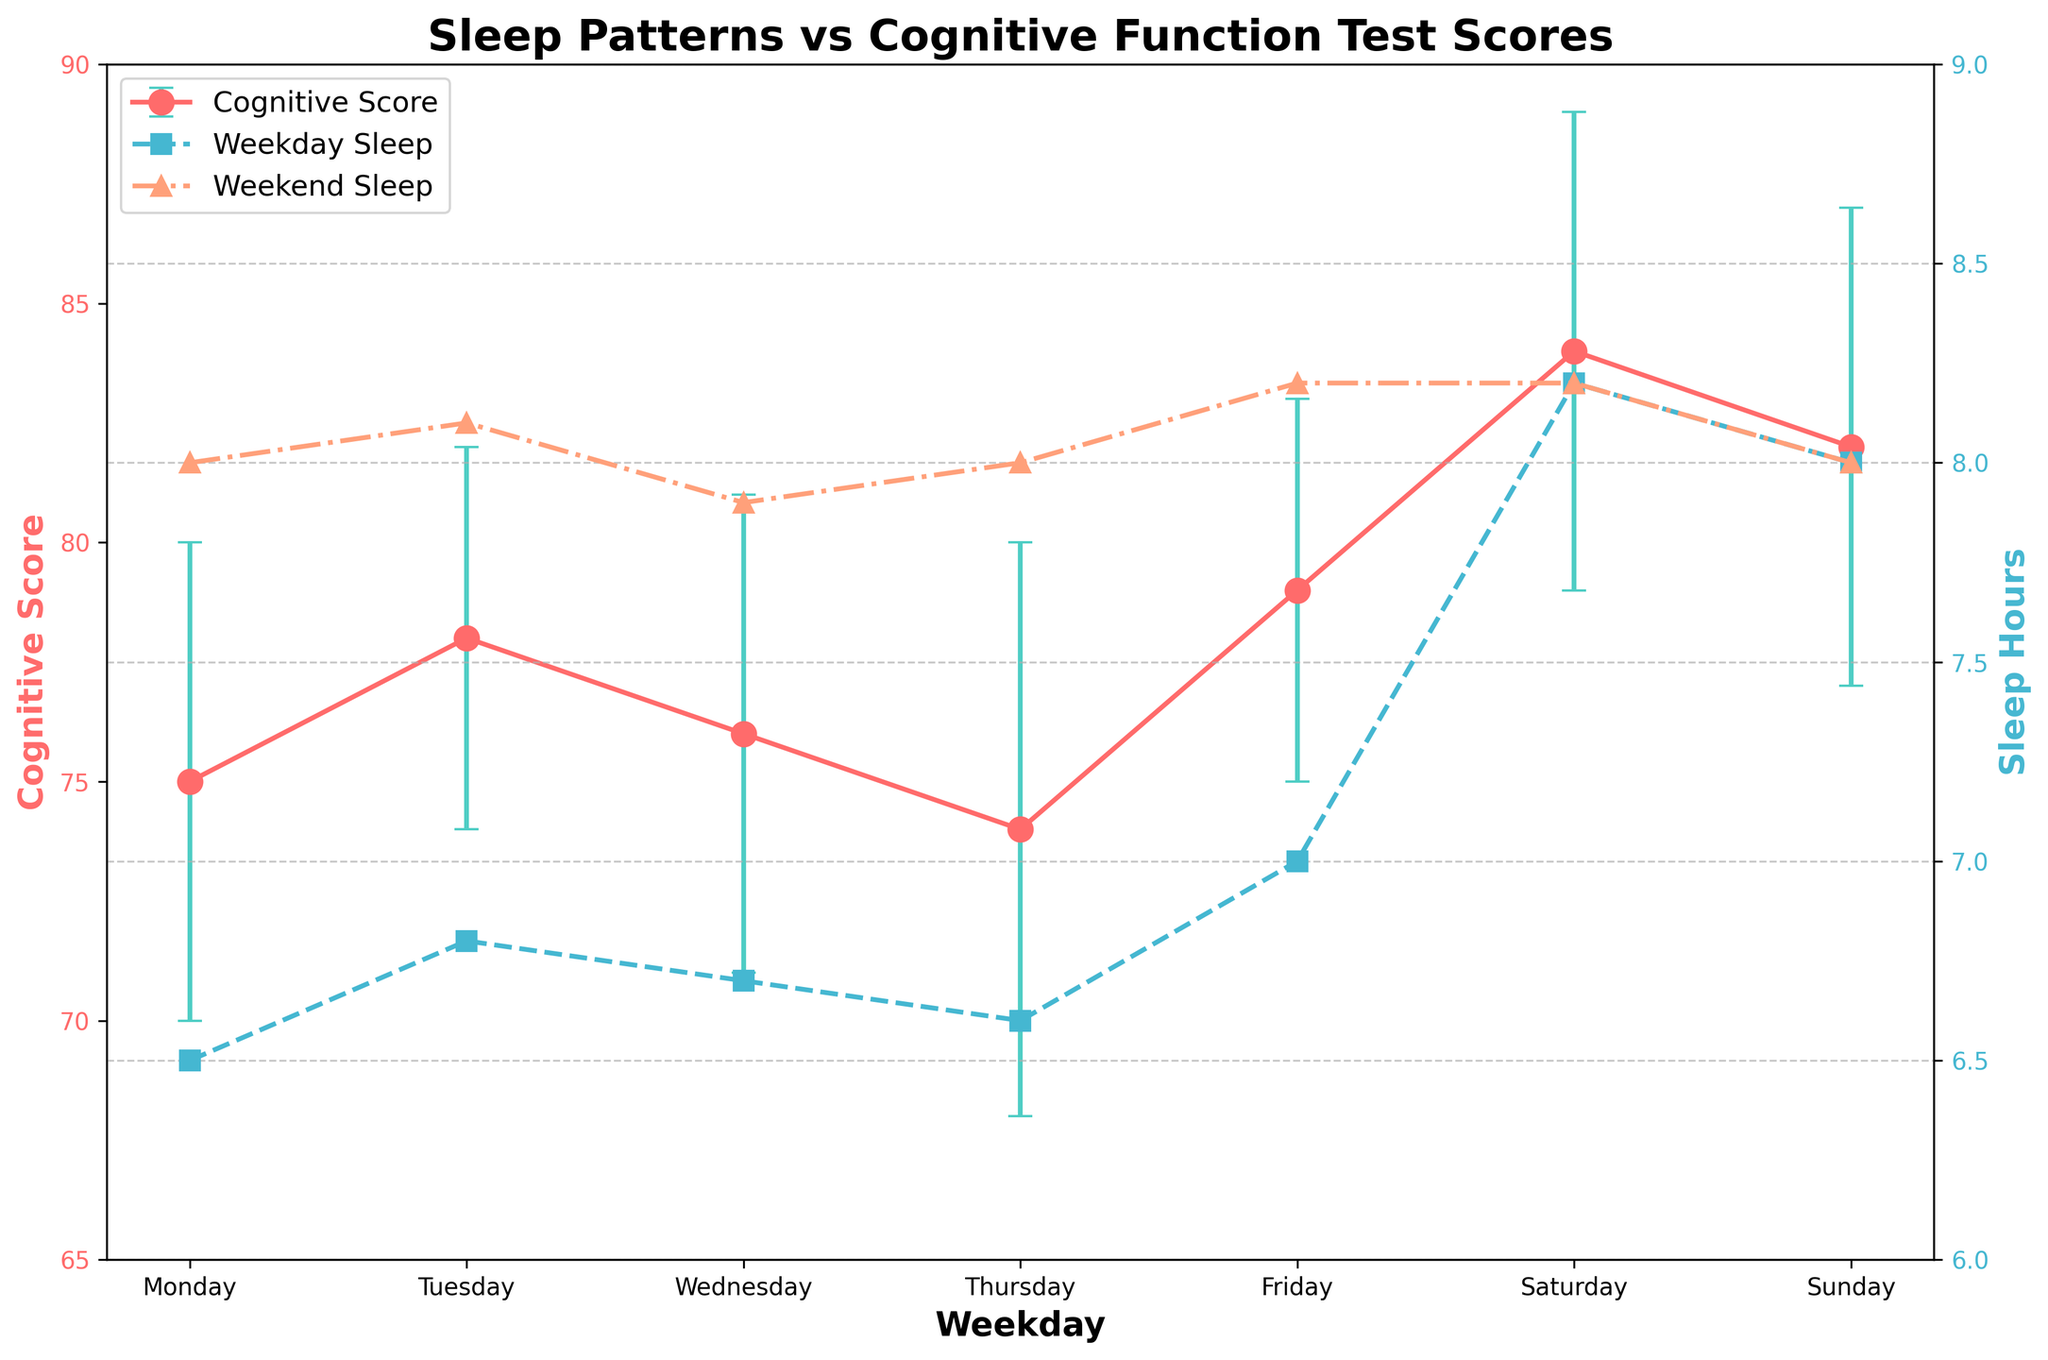What is the title of the figure? The title is usually located at the top of the figure and specifies the main subject of the data visualization. In this figure, the title is "Sleep Patterns vs Cognitive Function Test Scores".
Answer: Sleep Patterns vs Cognitive Function Test Scores What are the y-axis labels for the two plots? There are two y-axes in the plot, one for cognitive scores and another for sleep hours. The left y-axis label indicates "Cognitive Score", and the right y-axis label indicates "Sleep Hours".
Answer: Cognitive Score and Sleep Hours Which day has the highest cognitive score? To find the highest cognitive score, look at the points plotted on the primary y-axis and identify the maximum value. Saturday has the highest cognitive score of 84.
Answer: Saturday By how much do the cognitive test scores differ between Monday and Friday? The cognitive scores for Monday and Friday can be read from the plot. Monday has a score of 75, and Friday has a score of 79. The difference is 79 - 75 = 4.
Answer: 4 How does weekend sleep compare to weekday sleep? To compare weekend and weekday sleep, examine the lines and points for sleep hours. Weekend sleep hours are consistently higher than weekday sleep hours throughout the week.
Answer: Weekend sleep is higher Which day shows the largest error in cognitive score? The error bars indicate the standard deviation in cognitive scores. By observing the longest error bar among all days, Thursday shows the largest error of 6.
Answer: Thursday What is the average cognitive score from Monday to Thursday? The cognitive scores from Monday to Thursday are 75, 78, 76, and 74 respectively. Summing these gives 75 + 78 + 76 + 74 = 303, and there are 4 days, so the average is 303 / 4 = 75.75.
Answer: 75.75 On which day does weekday sleep reach its maximum, and what is the value? By observing the weekday sleep plot (squares), the maximum value occurs on Saturday, with 8.2 sleep hours.
Answer: Saturday, 8.2 hours What is the difference in cognitive scores between the day with the highest and the day with the lowest score? The highest cognitive score is on Saturday with 84, and the lowest is on Thursday with 74. The difference is 84 - 74 = 10.
Answer: 10 What relationship can you infer between sleep hours and cognitive scores during weekdays? By comparing weekday sleep hours with cognitive scores, it indicates that higher sleep hours generally correspond with higher cognitive scores but vary slightly day to day.
Answer: Higher sleep generally equals higher cognitive scores 